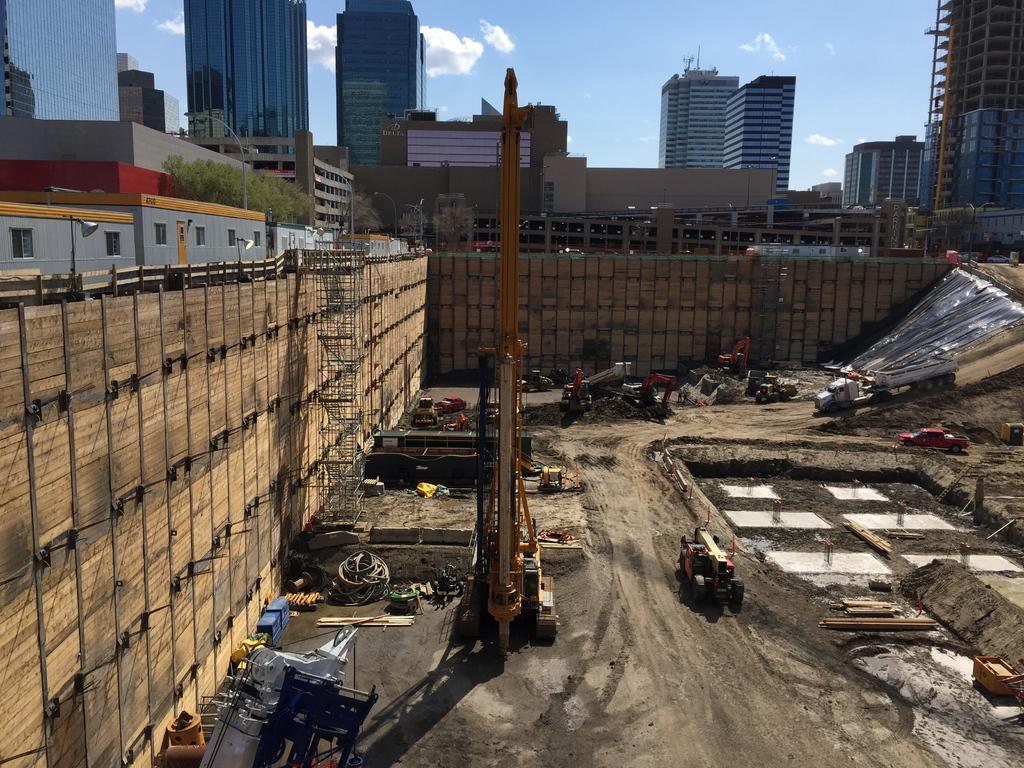Please provide a concise description of this image. In this image we can see a crane and a group of vehicles parked on the ground. On the backside we can see a group of buildings, plants, a street pole and the sky which looks cloudy. 